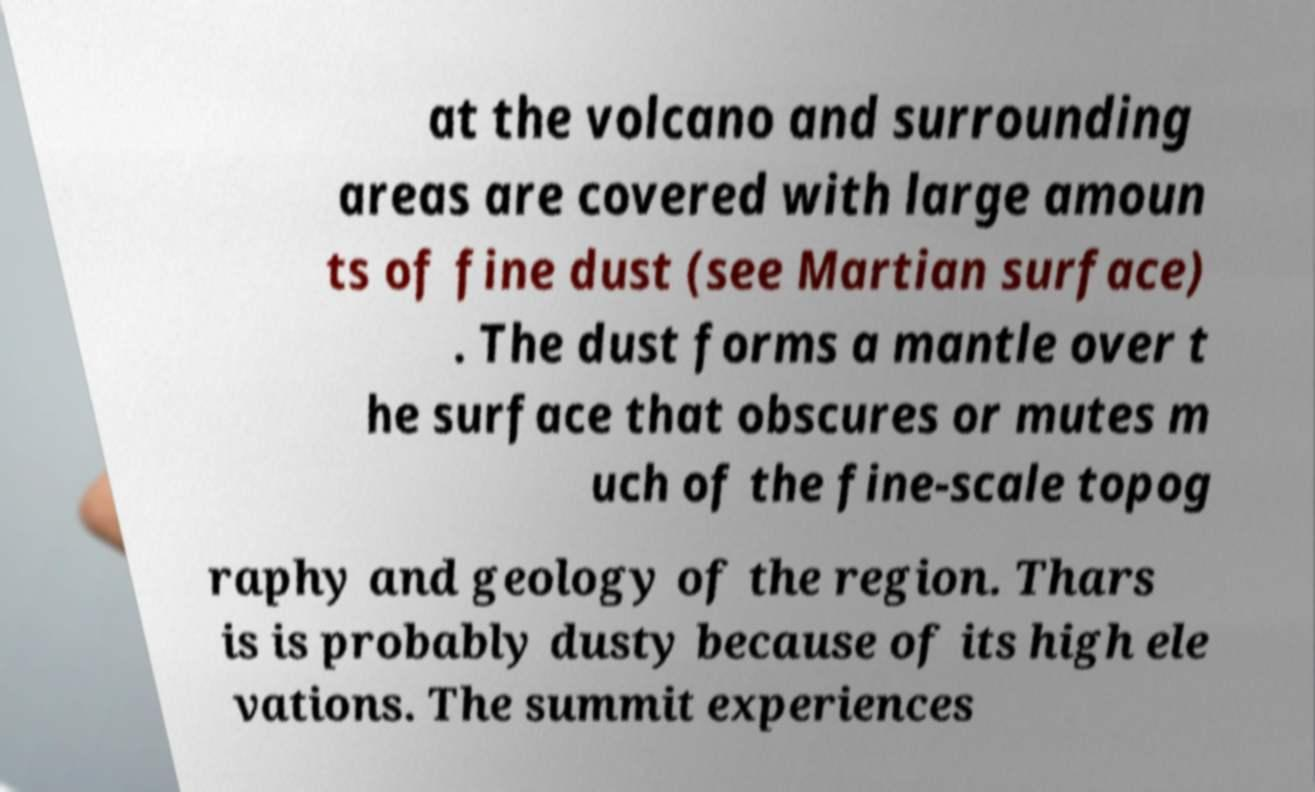Could you extract and type out the text from this image? at the volcano and surrounding areas are covered with large amoun ts of fine dust (see Martian surface) . The dust forms a mantle over t he surface that obscures or mutes m uch of the fine-scale topog raphy and geology of the region. Thars is is probably dusty because of its high ele vations. The summit experiences 